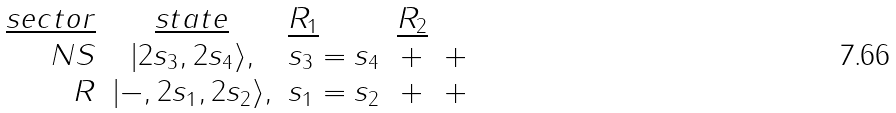Convert formula to latex. <formula><loc_0><loc_0><loc_500><loc_500>\begin{array} { r c l c c c c } { { \underline { s e c t o r } } } & { { \underline { s t a t e } } } & { { \underline { { { R _ { 1 } } } } } } & { { \underline { { { R _ { 2 } } } } } } \\ { N S } & { { | 2 s _ { 3 } , 2 s _ { 4 } \rangle , } } & { { s _ { 3 } = s _ { 4 } } } & { + } & { + } \\ { R } & { { | - , 2 s _ { 1 } , 2 s _ { 2 } \rangle , } } & { { s _ { 1 } = s _ { 2 } } } & { + } & { + } \end{array}</formula> 